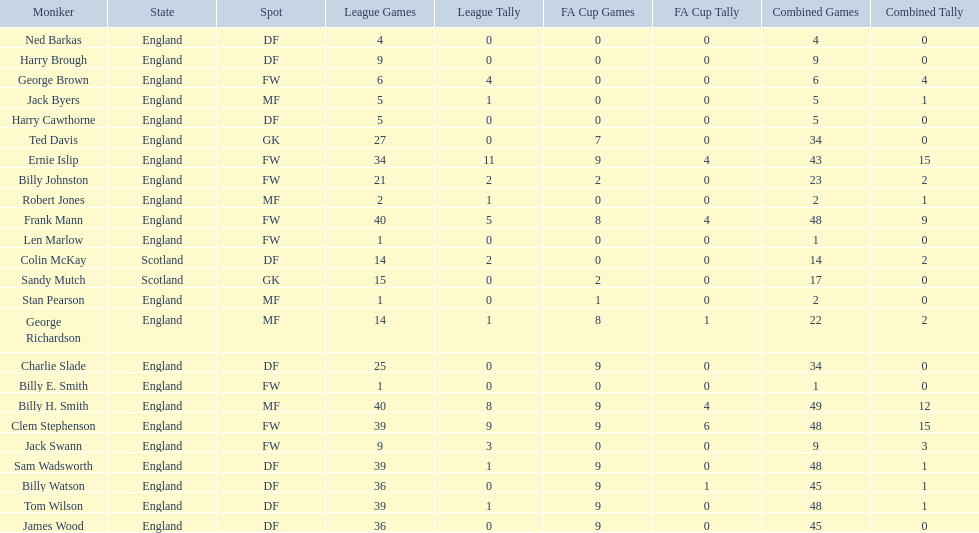Average number of goals scored by players from scotland 1. 